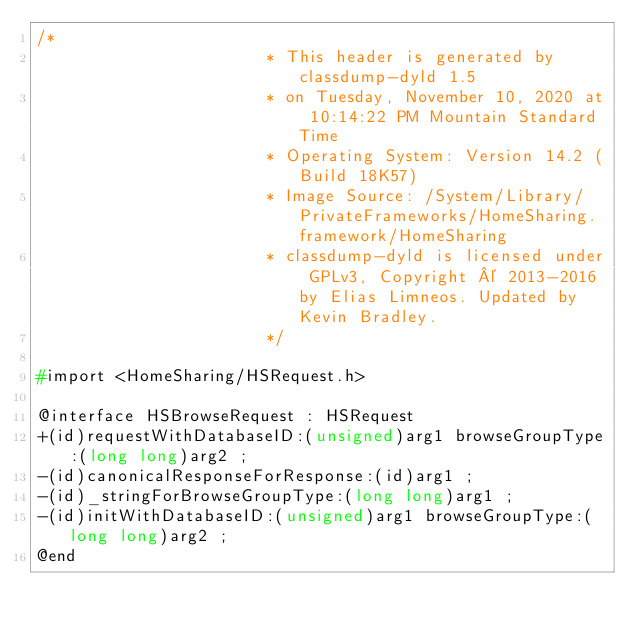<code> <loc_0><loc_0><loc_500><loc_500><_C_>/*
                       * This header is generated by classdump-dyld 1.5
                       * on Tuesday, November 10, 2020 at 10:14:22 PM Mountain Standard Time
                       * Operating System: Version 14.2 (Build 18K57)
                       * Image Source: /System/Library/PrivateFrameworks/HomeSharing.framework/HomeSharing
                       * classdump-dyld is licensed under GPLv3, Copyright © 2013-2016 by Elias Limneos. Updated by Kevin Bradley.
                       */

#import <HomeSharing/HSRequest.h>

@interface HSBrowseRequest : HSRequest
+(id)requestWithDatabaseID:(unsigned)arg1 browseGroupType:(long long)arg2 ;
-(id)canonicalResponseForResponse:(id)arg1 ;
-(id)_stringForBrowseGroupType:(long long)arg1 ;
-(id)initWithDatabaseID:(unsigned)arg1 browseGroupType:(long long)arg2 ;
@end

</code> 